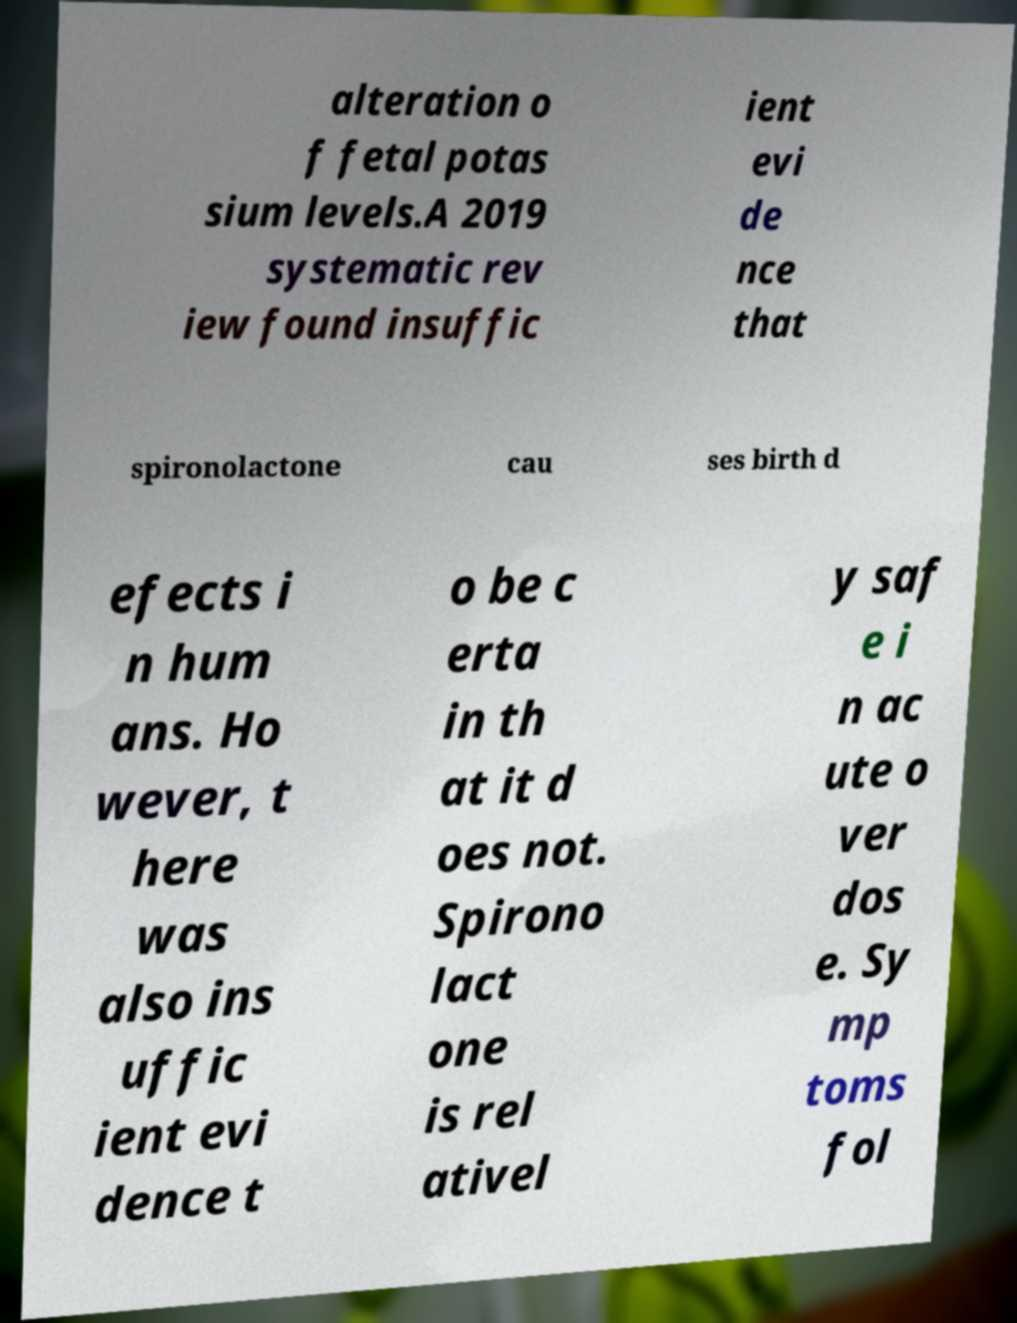Can you read and provide the text displayed in the image?This photo seems to have some interesting text. Can you extract and type it out for me? alteration o f fetal potas sium levels.A 2019 systematic rev iew found insuffic ient evi de nce that spironolactone cau ses birth d efects i n hum ans. Ho wever, t here was also ins uffic ient evi dence t o be c erta in th at it d oes not. Spirono lact one is rel ativel y saf e i n ac ute o ver dos e. Sy mp toms fol 